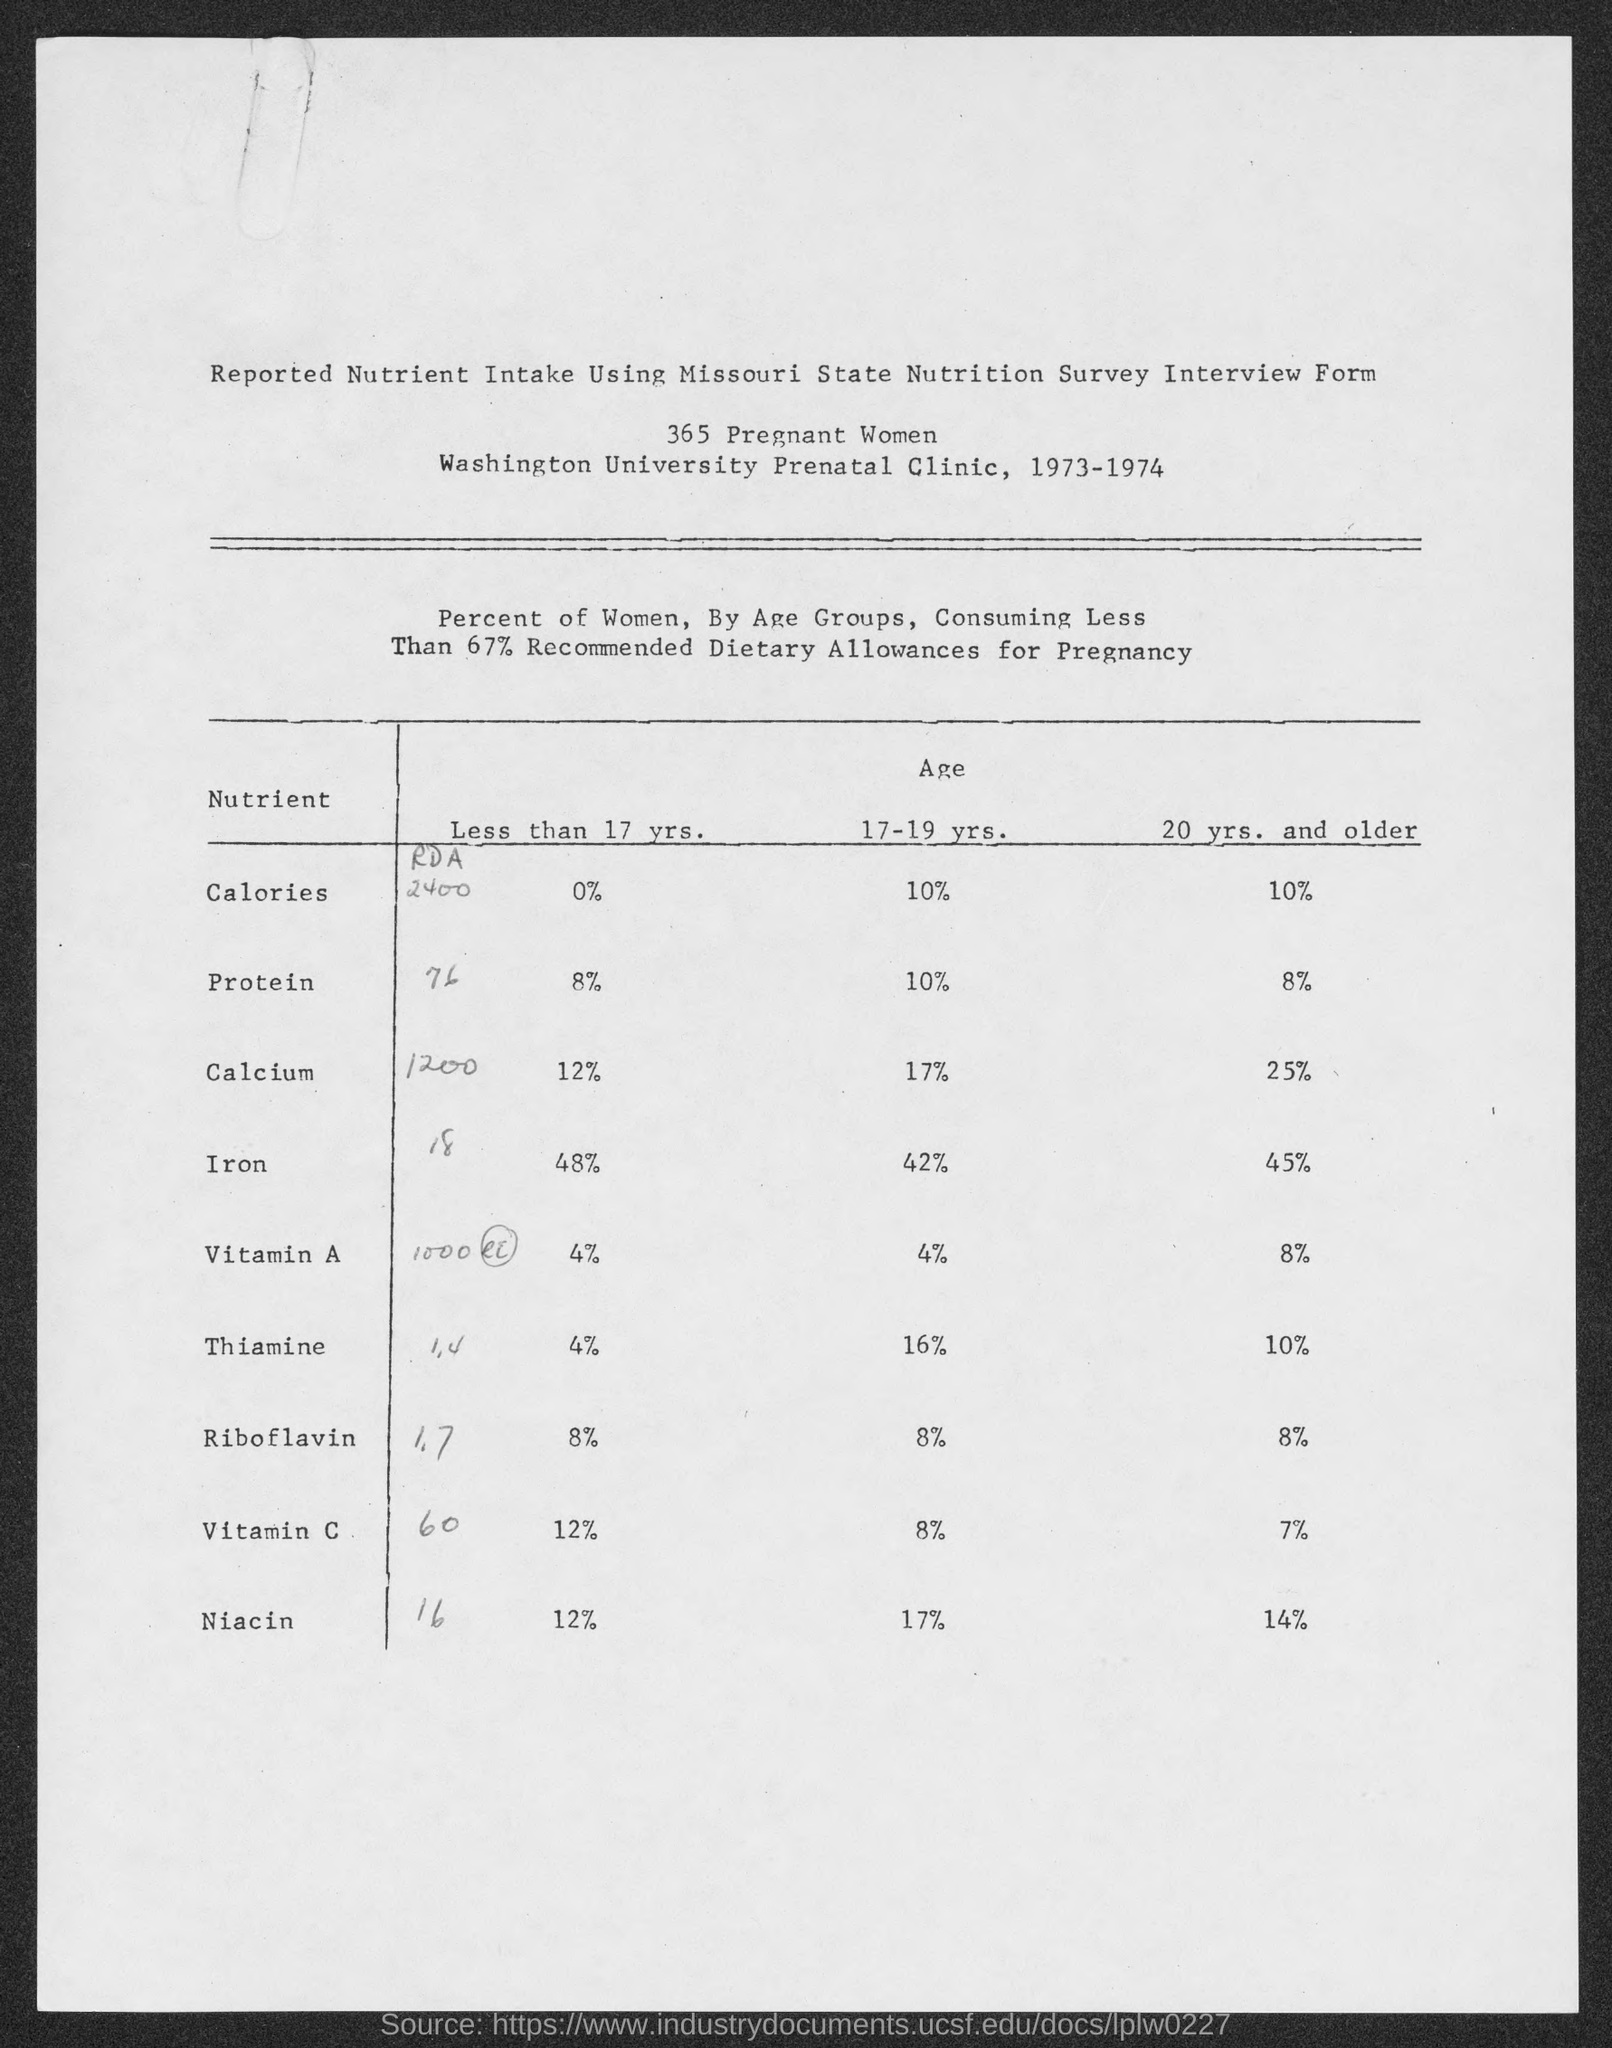What is the percent of calories for women less than 17 yrs?
Your answer should be very brief. 0%. What is the percent of Protein for women less than 17 yrs?
Give a very brief answer. 8%. What is the percent of Calcium for women less than 17 yrs?
Provide a short and direct response. 12%. What is the percent of Iron for women less than 17 yrs?
Give a very brief answer. 48%. What is the percent of Vitamin A for women less than 17 yrs?
Offer a very short reply. 4%. What is the percent of Thiamine for women less than 17 yrs?
Provide a short and direct response. 4%. What is the percent of Riboflavin for women less than 17 yrs?
Ensure brevity in your answer.  8%. What is the percent of Vitamin C for women less than 17 yrs?
Keep it short and to the point. 12%. What is the percent of Niacin for women less than 17 yrs?
Your answer should be compact. 12%. What is the percent of Calcium for women whose age is  17 - 19 yrs?
Offer a terse response. 17%. 